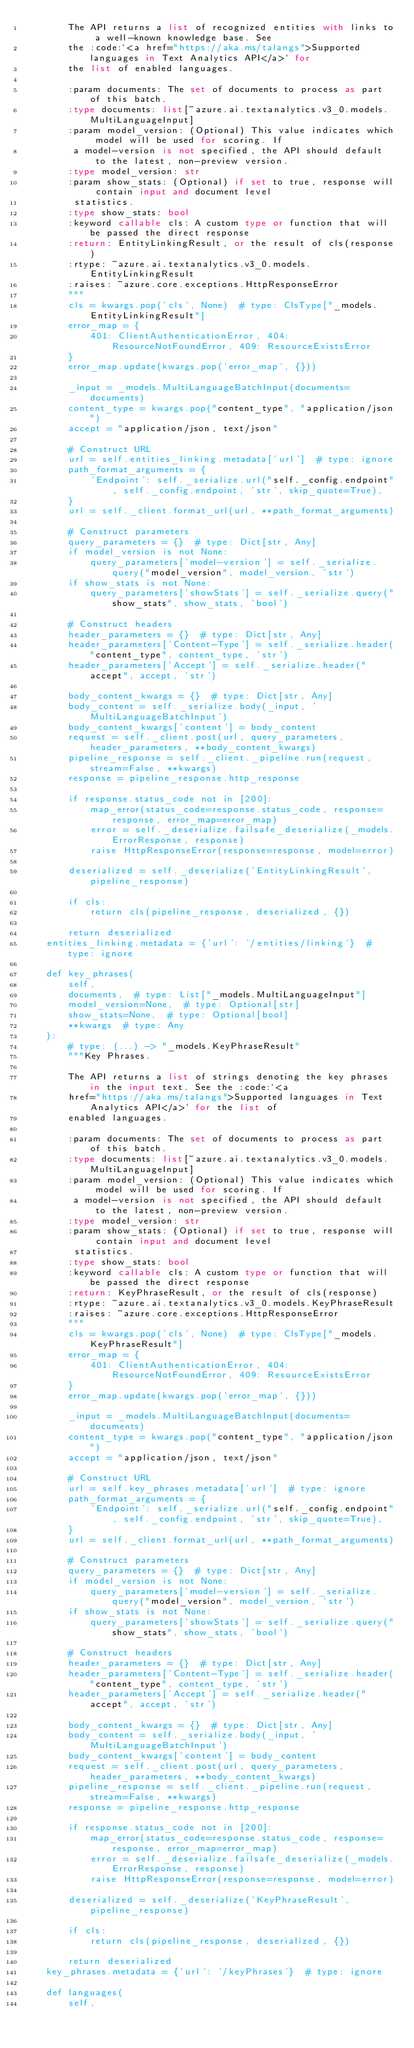<code> <loc_0><loc_0><loc_500><loc_500><_Python_>        The API returns a list of recognized entities with links to a well-known knowledge base. See
        the :code:`<a href="https://aka.ms/talangs">Supported languages in Text Analytics API</a>` for
        the list of enabled languages.

        :param documents: The set of documents to process as part of this batch.
        :type documents: list[~azure.ai.textanalytics.v3_0.models.MultiLanguageInput]
        :param model_version: (Optional) This value indicates which model will be used for scoring. If
         a model-version is not specified, the API should default to the latest, non-preview version.
        :type model_version: str
        :param show_stats: (Optional) if set to true, response will contain input and document level
         statistics.
        :type show_stats: bool
        :keyword callable cls: A custom type or function that will be passed the direct response
        :return: EntityLinkingResult, or the result of cls(response)
        :rtype: ~azure.ai.textanalytics.v3_0.models.EntityLinkingResult
        :raises: ~azure.core.exceptions.HttpResponseError
        """
        cls = kwargs.pop('cls', None)  # type: ClsType["_models.EntityLinkingResult"]
        error_map = {
            401: ClientAuthenticationError, 404: ResourceNotFoundError, 409: ResourceExistsError
        }
        error_map.update(kwargs.pop('error_map', {}))

        _input = _models.MultiLanguageBatchInput(documents=documents)
        content_type = kwargs.pop("content_type", "application/json")
        accept = "application/json, text/json"

        # Construct URL
        url = self.entities_linking.metadata['url']  # type: ignore
        path_format_arguments = {
            'Endpoint': self._serialize.url("self._config.endpoint", self._config.endpoint, 'str', skip_quote=True),
        }
        url = self._client.format_url(url, **path_format_arguments)

        # Construct parameters
        query_parameters = {}  # type: Dict[str, Any]
        if model_version is not None:
            query_parameters['model-version'] = self._serialize.query("model_version", model_version, 'str')
        if show_stats is not None:
            query_parameters['showStats'] = self._serialize.query("show_stats", show_stats, 'bool')

        # Construct headers
        header_parameters = {}  # type: Dict[str, Any]
        header_parameters['Content-Type'] = self._serialize.header("content_type", content_type, 'str')
        header_parameters['Accept'] = self._serialize.header("accept", accept, 'str')

        body_content_kwargs = {}  # type: Dict[str, Any]
        body_content = self._serialize.body(_input, 'MultiLanguageBatchInput')
        body_content_kwargs['content'] = body_content
        request = self._client.post(url, query_parameters, header_parameters, **body_content_kwargs)
        pipeline_response = self._client._pipeline.run(request, stream=False, **kwargs)
        response = pipeline_response.http_response

        if response.status_code not in [200]:
            map_error(status_code=response.status_code, response=response, error_map=error_map)
            error = self._deserialize.failsafe_deserialize(_models.ErrorResponse, response)
            raise HttpResponseError(response=response, model=error)

        deserialized = self._deserialize('EntityLinkingResult', pipeline_response)

        if cls:
            return cls(pipeline_response, deserialized, {})

        return deserialized
    entities_linking.metadata = {'url': '/entities/linking'}  # type: ignore

    def key_phrases(
        self,
        documents,  # type: List["_models.MultiLanguageInput"]
        model_version=None,  # type: Optional[str]
        show_stats=None,  # type: Optional[bool]
        **kwargs  # type: Any
    ):
        # type: (...) -> "_models.KeyPhraseResult"
        """Key Phrases.

        The API returns a list of strings denoting the key phrases in the input text. See the :code:`<a
        href="https://aka.ms/talangs">Supported languages in Text Analytics API</a>` for the list of
        enabled languages.

        :param documents: The set of documents to process as part of this batch.
        :type documents: list[~azure.ai.textanalytics.v3_0.models.MultiLanguageInput]
        :param model_version: (Optional) This value indicates which model will be used for scoring. If
         a model-version is not specified, the API should default to the latest, non-preview version.
        :type model_version: str
        :param show_stats: (Optional) if set to true, response will contain input and document level
         statistics.
        :type show_stats: bool
        :keyword callable cls: A custom type or function that will be passed the direct response
        :return: KeyPhraseResult, or the result of cls(response)
        :rtype: ~azure.ai.textanalytics.v3_0.models.KeyPhraseResult
        :raises: ~azure.core.exceptions.HttpResponseError
        """
        cls = kwargs.pop('cls', None)  # type: ClsType["_models.KeyPhraseResult"]
        error_map = {
            401: ClientAuthenticationError, 404: ResourceNotFoundError, 409: ResourceExistsError
        }
        error_map.update(kwargs.pop('error_map', {}))

        _input = _models.MultiLanguageBatchInput(documents=documents)
        content_type = kwargs.pop("content_type", "application/json")
        accept = "application/json, text/json"

        # Construct URL
        url = self.key_phrases.metadata['url']  # type: ignore
        path_format_arguments = {
            'Endpoint': self._serialize.url("self._config.endpoint", self._config.endpoint, 'str', skip_quote=True),
        }
        url = self._client.format_url(url, **path_format_arguments)

        # Construct parameters
        query_parameters = {}  # type: Dict[str, Any]
        if model_version is not None:
            query_parameters['model-version'] = self._serialize.query("model_version", model_version, 'str')
        if show_stats is not None:
            query_parameters['showStats'] = self._serialize.query("show_stats", show_stats, 'bool')

        # Construct headers
        header_parameters = {}  # type: Dict[str, Any]
        header_parameters['Content-Type'] = self._serialize.header("content_type", content_type, 'str')
        header_parameters['Accept'] = self._serialize.header("accept", accept, 'str')

        body_content_kwargs = {}  # type: Dict[str, Any]
        body_content = self._serialize.body(_input, 'MultiLanguageBatchInput')
        body_content_kwargs['content'] = body_content
        request = self._client.post(url, query_parameters, header_parameters, **body_content_kwargs)
        pipeline_response = self._client._pipeline.run(request, stream=False, **kwargs)
        response = pipeline_response.http_response

        if response.status_code not in [200]:
            map_error(status_code=response.status_code, response=response, error_map=error_map)
            error = self._deserialize.failsafe_deserialize(_models.ErrorResponse, response)
            raise HttpResponseError(response=response, model=error)

        deserialized = self._deserialize('KeyPhraseResult', pipeline_response)

        if cls:
            return cls(pipeline_response, deserialized, {})

        return deserialized
    key_phrases.metadata = {'url': '/keyPhrases'}  # type: ignore

    def languages(
        self,</code> 